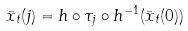Convert formula to latex. <formula><loc_0><loc_0><loc_500><loc_500>\bar { x } _ { t } ( j ) = h \circ \tau _ { j } \circ h ^ { - 1 } ( \bar { x } _ { t } ( 0 ) )</formula> 